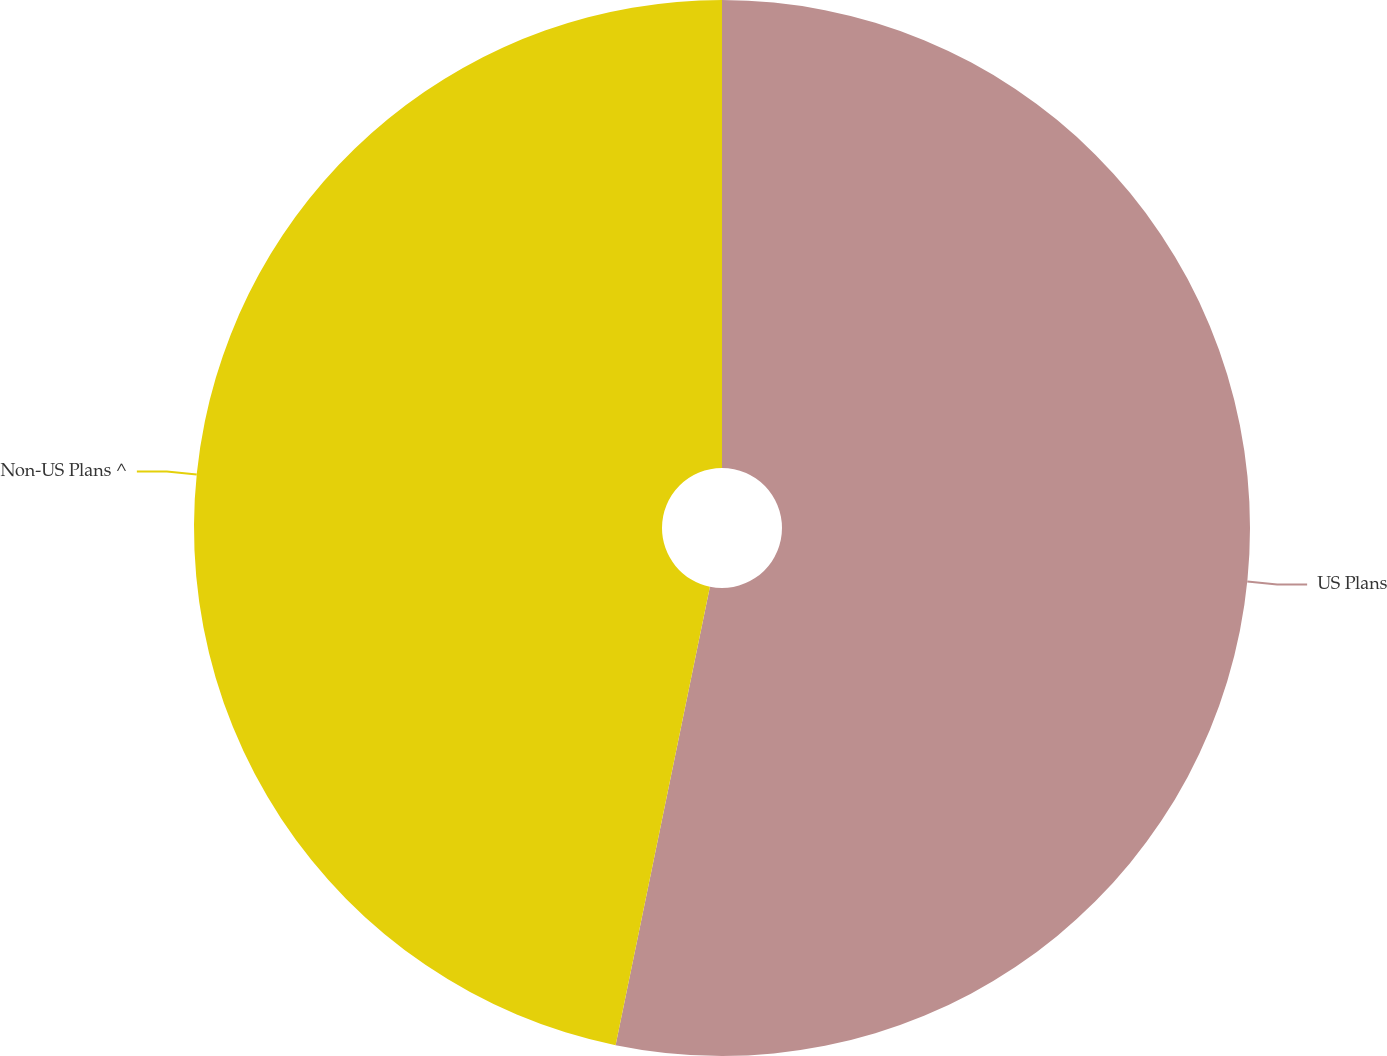Convert chart to OTSL. <chart><loc_0><loc_0><loc_500><loc_500><pie_chart><fcel>US Plans<fcel>Non-US Plans ^<nl><fcel>53.23%<fcel>46.77%<nl></chart> 